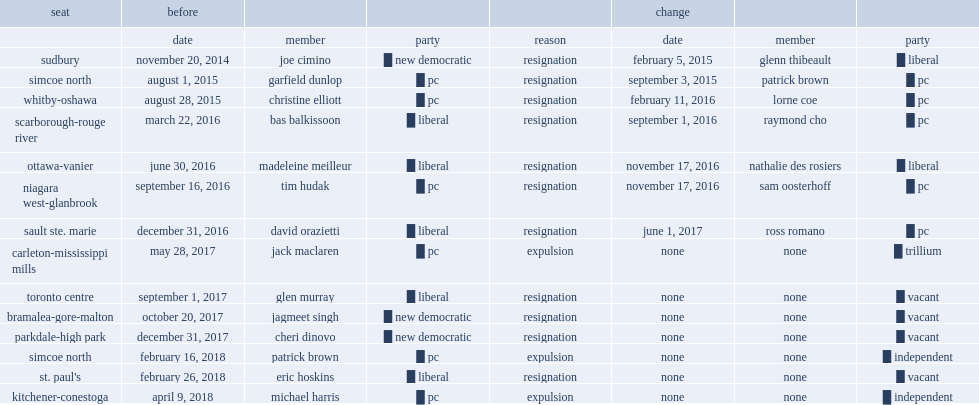When did patrick brown eject from simcoe north? February 16, 2018. 